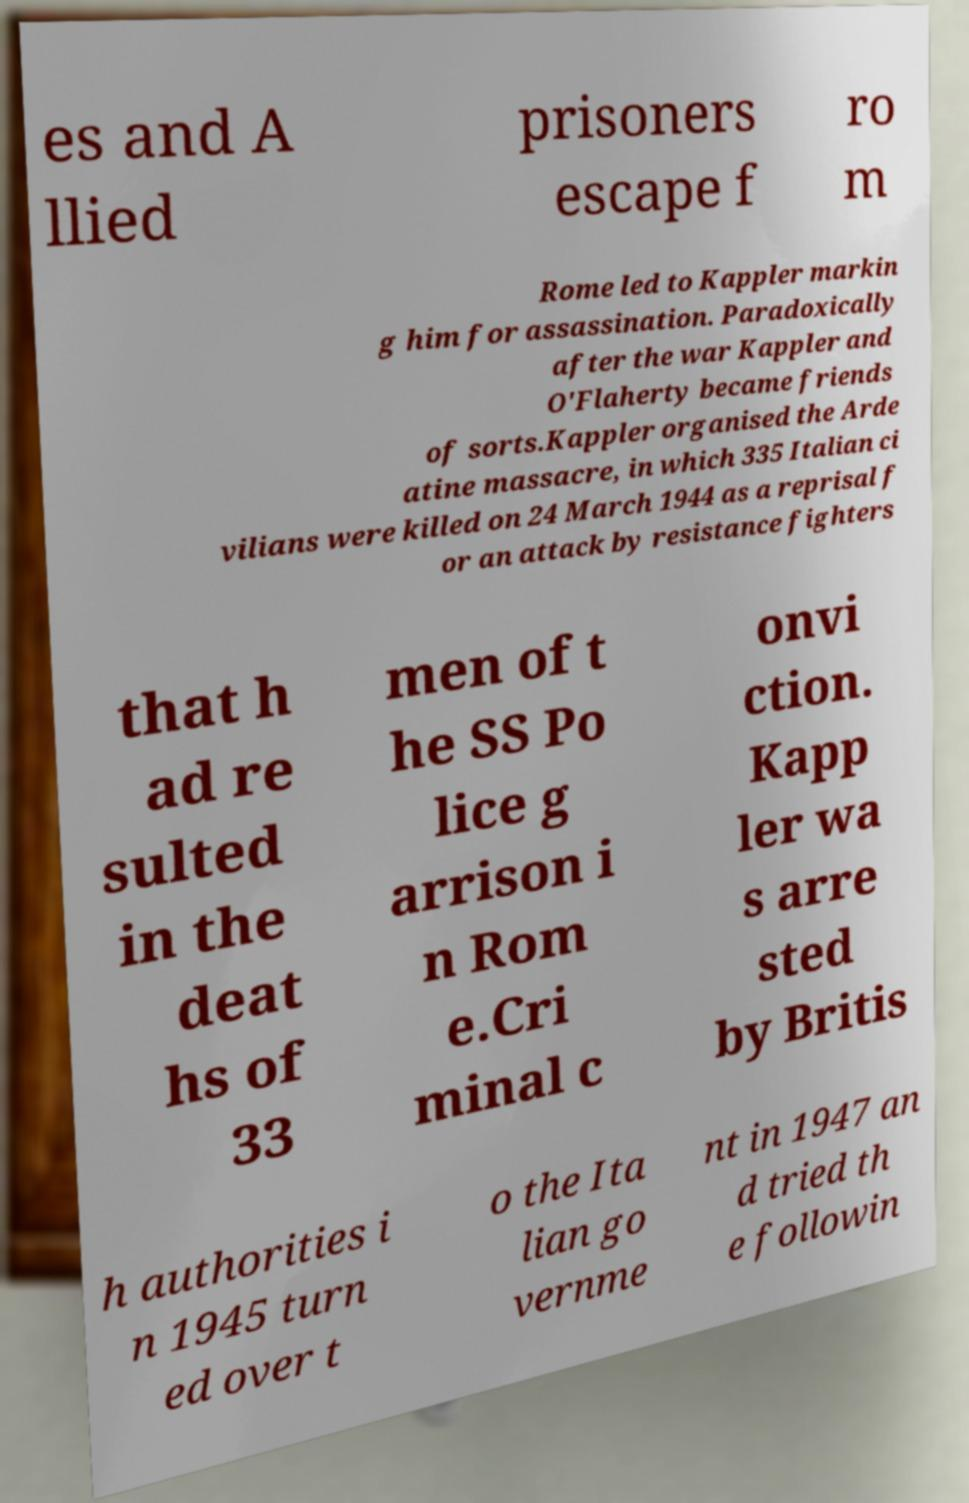Can you accurately transcribe the text from the provided image for me? es and A llied prisoners escape f ro m Rome led to Kappler markin g him for assassination. Paradoxically after the war Kappler and O'Flaherty became friends of sorts.Kappler organised the Arde atine massacre, in which 335 Italian ci vilians were killed on 24 March 1944 as a reprisal f or an attack by resistance fighters that h ad re sulted in the deat hs of 33 men of t he SS Po lice g arrison i n Rom e.Cri minal c onvi ction. Kapp ler wa s arre sted by Britis h authorities i n 1945 turn ed over t o the Ita lian go vernme nt in 1947 an d tried th e followin 